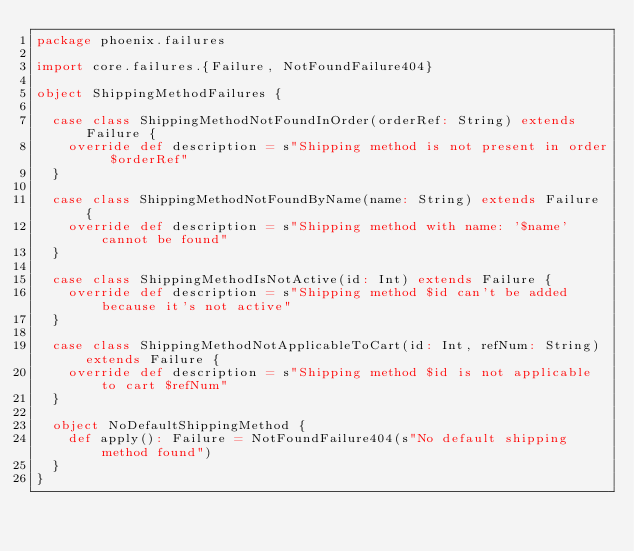<code> <loc_0><loc_0><loc_500><loc_500><_Scala_>package phoenix.failures

import core.failures.{Failure, NotFoundFailure404}

object ShippingMethodFailures {

  case class ShippingMethodNotFoundInOrder(orderRef: String) extends Failure {
    override def description = s"Shipping method is not present in order $orderRef"
  }

  case class ShippingMethodNotFoundByName(name: String) extends Failure {
    override def description = s"Shipping method with name: '$name' cannot be found"
  }

  case class ShippingMethodIsNotActive(id: Int) extends Failure {
    override def description = s"Shipping method $id can't be added because it's not active"
  }

  case class ShippingMethodNotApplicableToCart(id: Int, refNum: String) extends Failure {
    override def description = s"Shipping method $id is not applicable to cart $refNum"
  }

  object NoDefaultShippingMethod {
    def apply(): Failure = NotFoundFailure404(s"No default shipping method found")
  }
}
</code> 